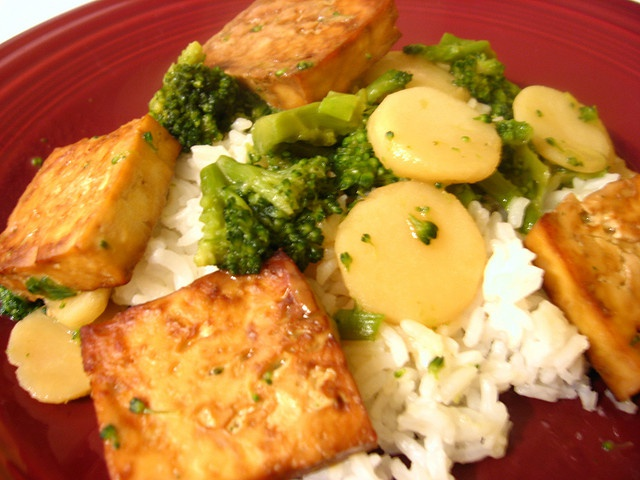Describe the objects in this image and their specific colors. I can see bowl in brown, orange, gold, and red tones, sandwich in white, orange, red, and gold tones, sandwich in white, red, and orange tones, broccoli in white, olive, black, and khaki tones, and broccoli in white, olive, and black tones in this image. 